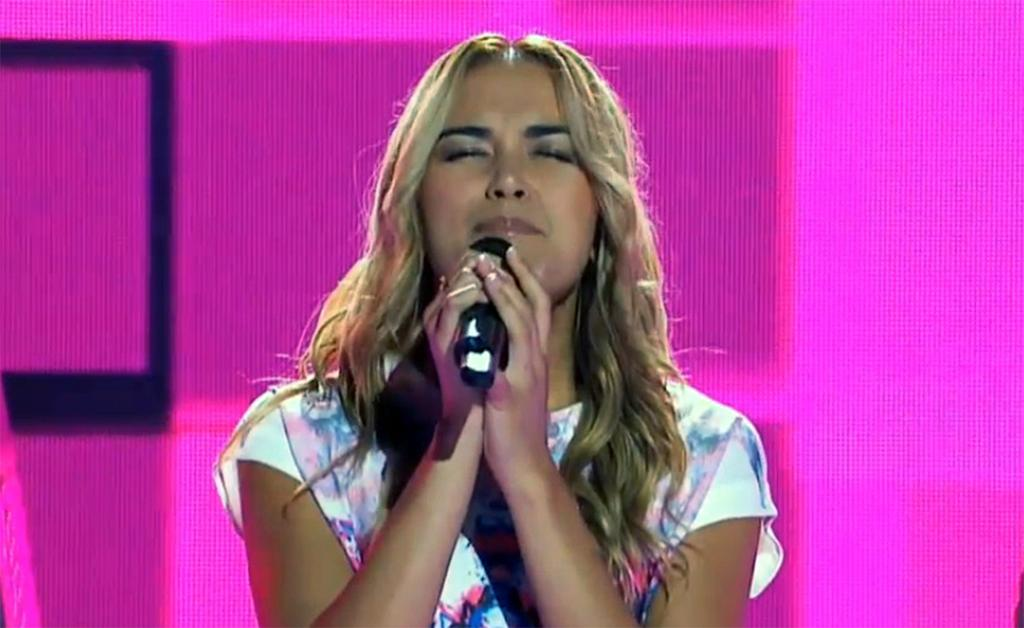Who is the main subject in the image? There is a woman in the image. What is the woman holding in the image? The woman is holding a mic. What can be seen behind the woman in the image? The background of the image is a pink screen. What type of expert advice can be heard from the woman in the image? There is no indication in the image that the woman is providing expert advice or speaking at all, as she is simply holding a mic. 